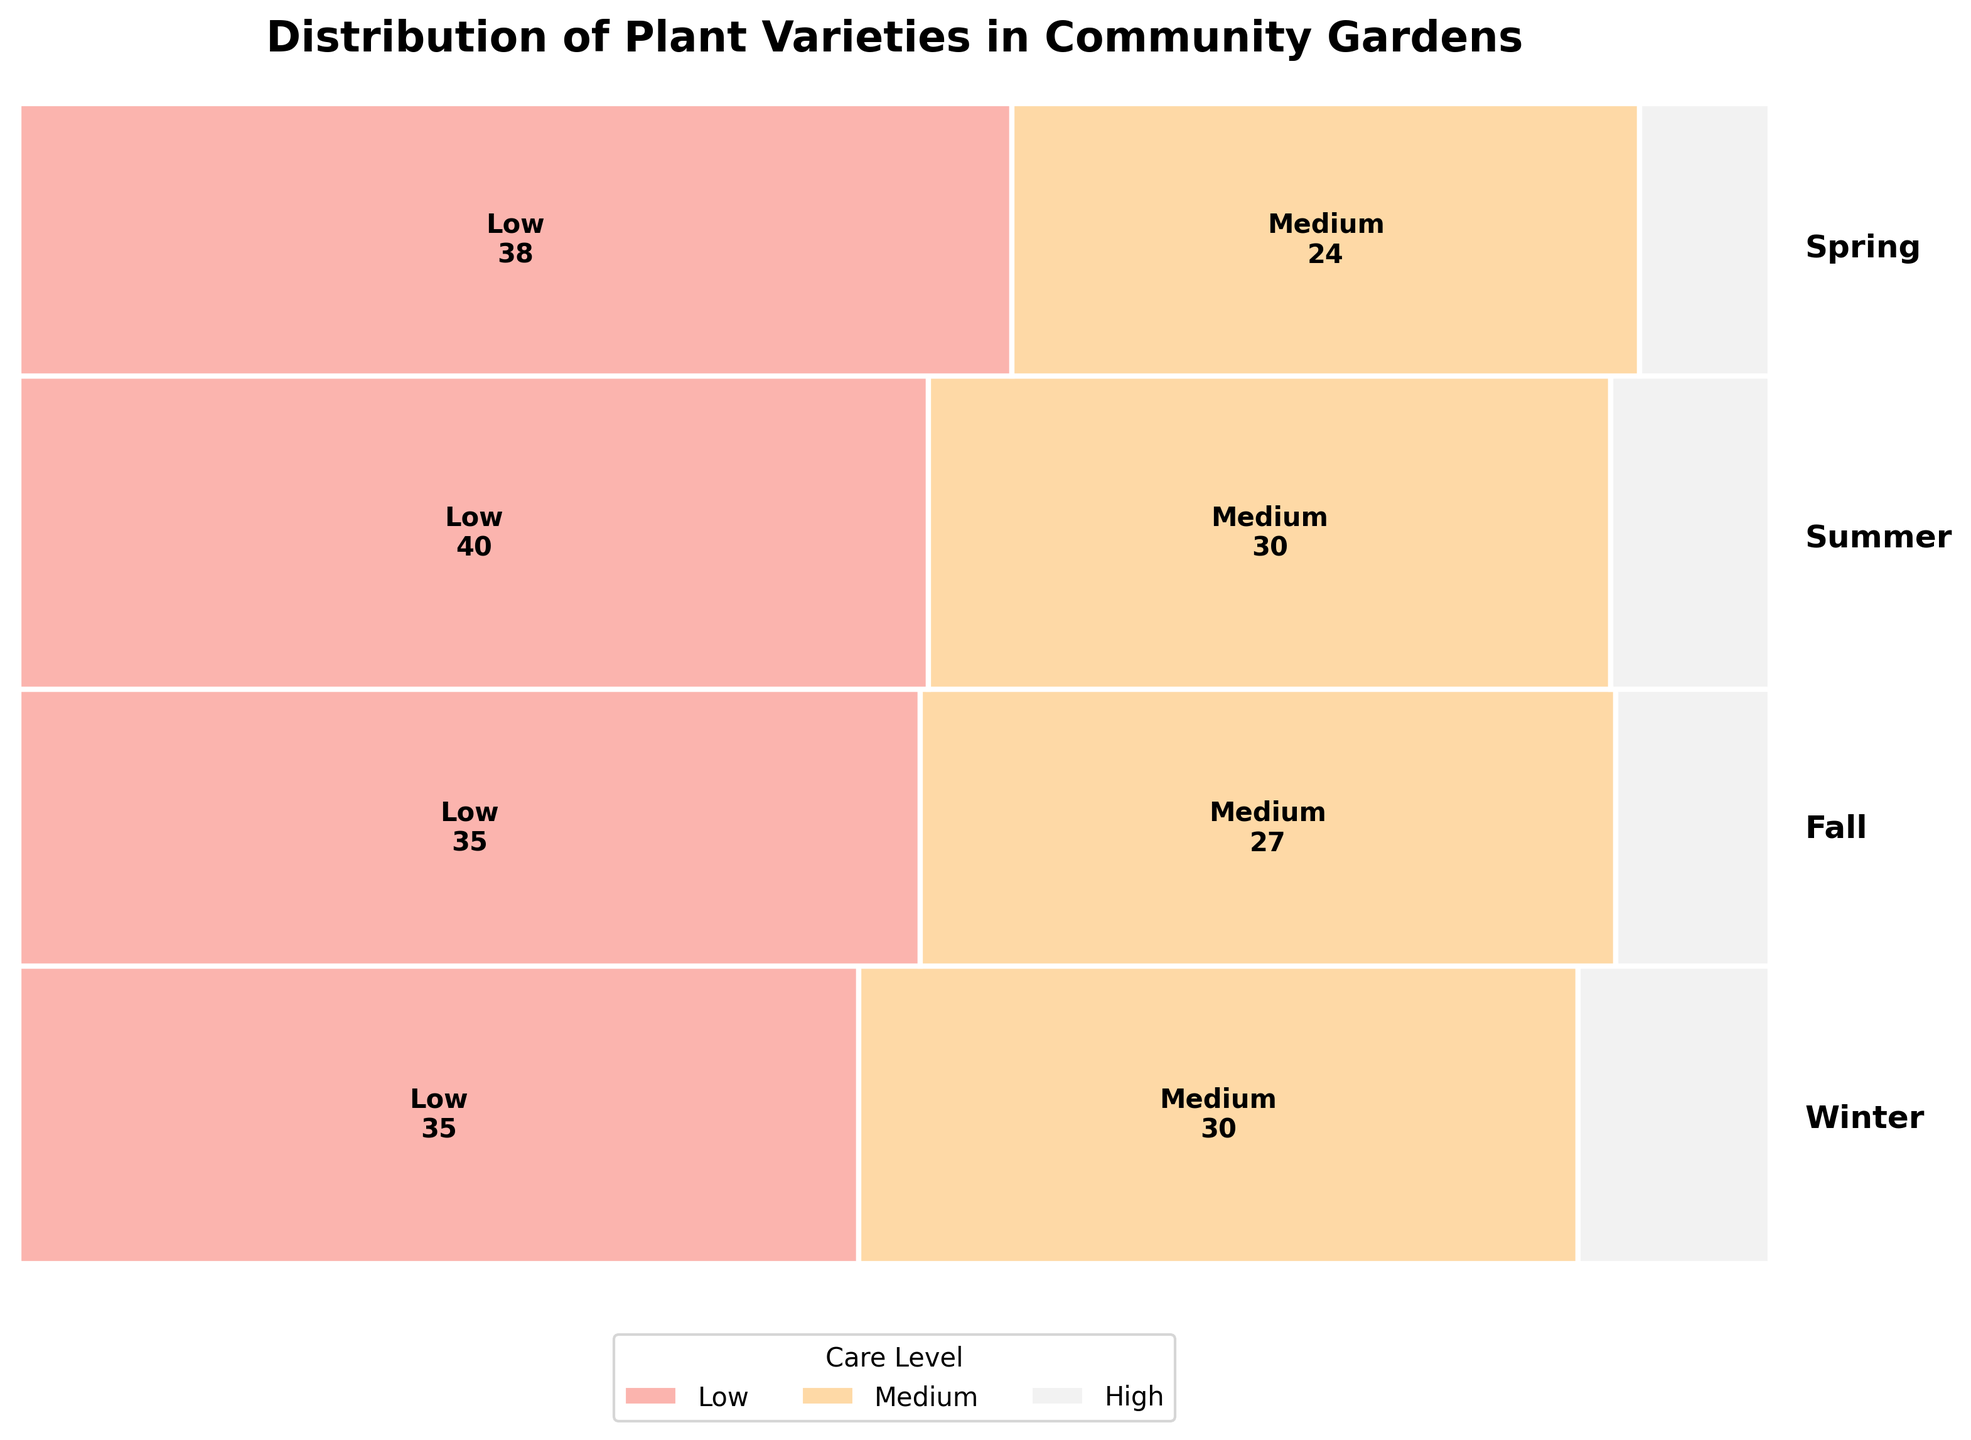What season has the highest count of plant varieties requiring low care? Spring, Summer, Fall, and Winter are divided into segments based on the care levels. Summer's area for low care is the largest.
Answer: Summer Which care level has the smallest area in Winter? Each care level area represents a different color per season. Among the segments for Winter, high care (Artichokes) is the smallest.
Answer: High What is the count of plant varieties requiring high care in Fall? Locate the Fall segment and identify the high care section. The number is displayed on the plot.
Answer: 7 Which season has the highest total count of plant varieties? Compare the heights of the segments for all seasons. Fall's segment is the tallest.
Answer: Fall Compare the area of medium care plant varieties between Spring and Winter. Which one is larger? Medium care areas for Spring and Winter plant varieties are represented visually. Spring's area is larger.
Answer: Spring How does the number of plant varieties requiring low care in Spring compare to the number in Fall? Check the low care sections for both Spring and Fall. Fall's count (Carrots and Kale, combined) is greater.
Answer: Fall What observation can be made about the distribution of high-care plant varieties across all seasons? Look at the visualization for high care across all four seasons. High care sections are the smallest in each season.
Answer: High care plant varieties are the least common Which care level is the most consistent in terms of area distribution across all seasons? Observe the areas for all care levels per season. Low care consistently covers the largest area in most seasons.
Answer: Low What are the counts for medium care plant varieties in Winter and Spring combined? From the plot, sum the counts for medium care in Winter (Broccoli and Cauliflower) and Spring (Peas and Spinach).
Answer: 54 In terms of area, which care level has the closest distribution across Spring and Summer? Compare the area sizes for specific care levels between Spring and Summer. Medium care areas in both seasons appear most similar.
Answer: Medium 